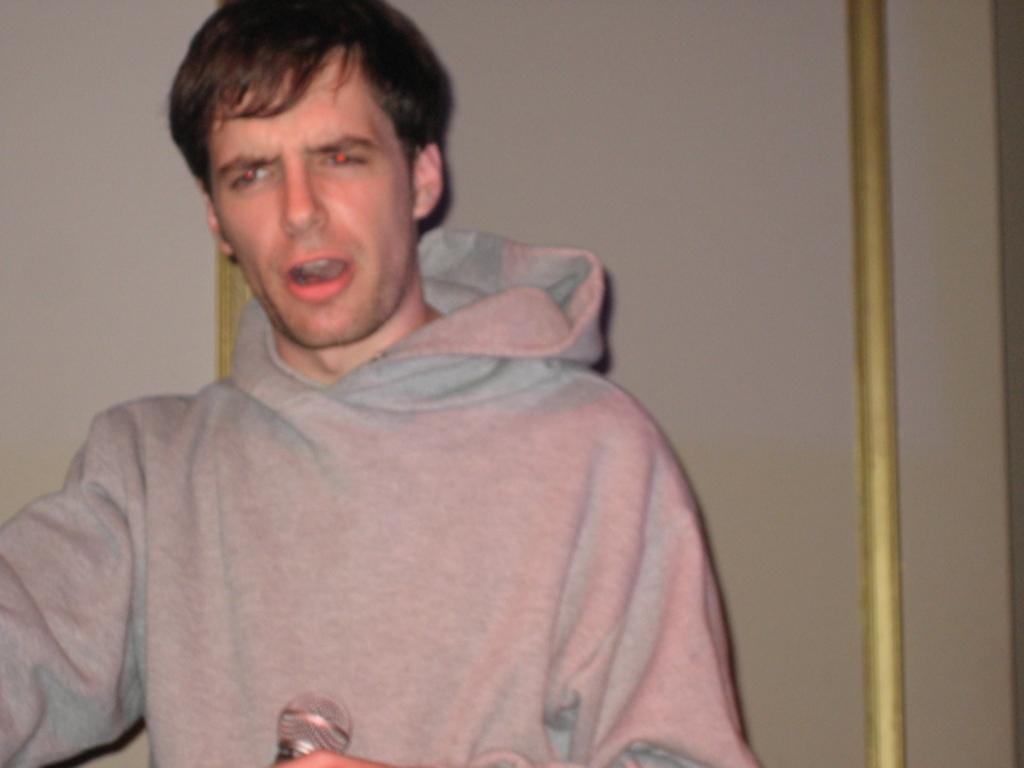How would you summarize this image in a sentence or two? In this picture I can observe a person wearing ash color hoodie. He is holding a mic in his hand. In the background there is a wall. 